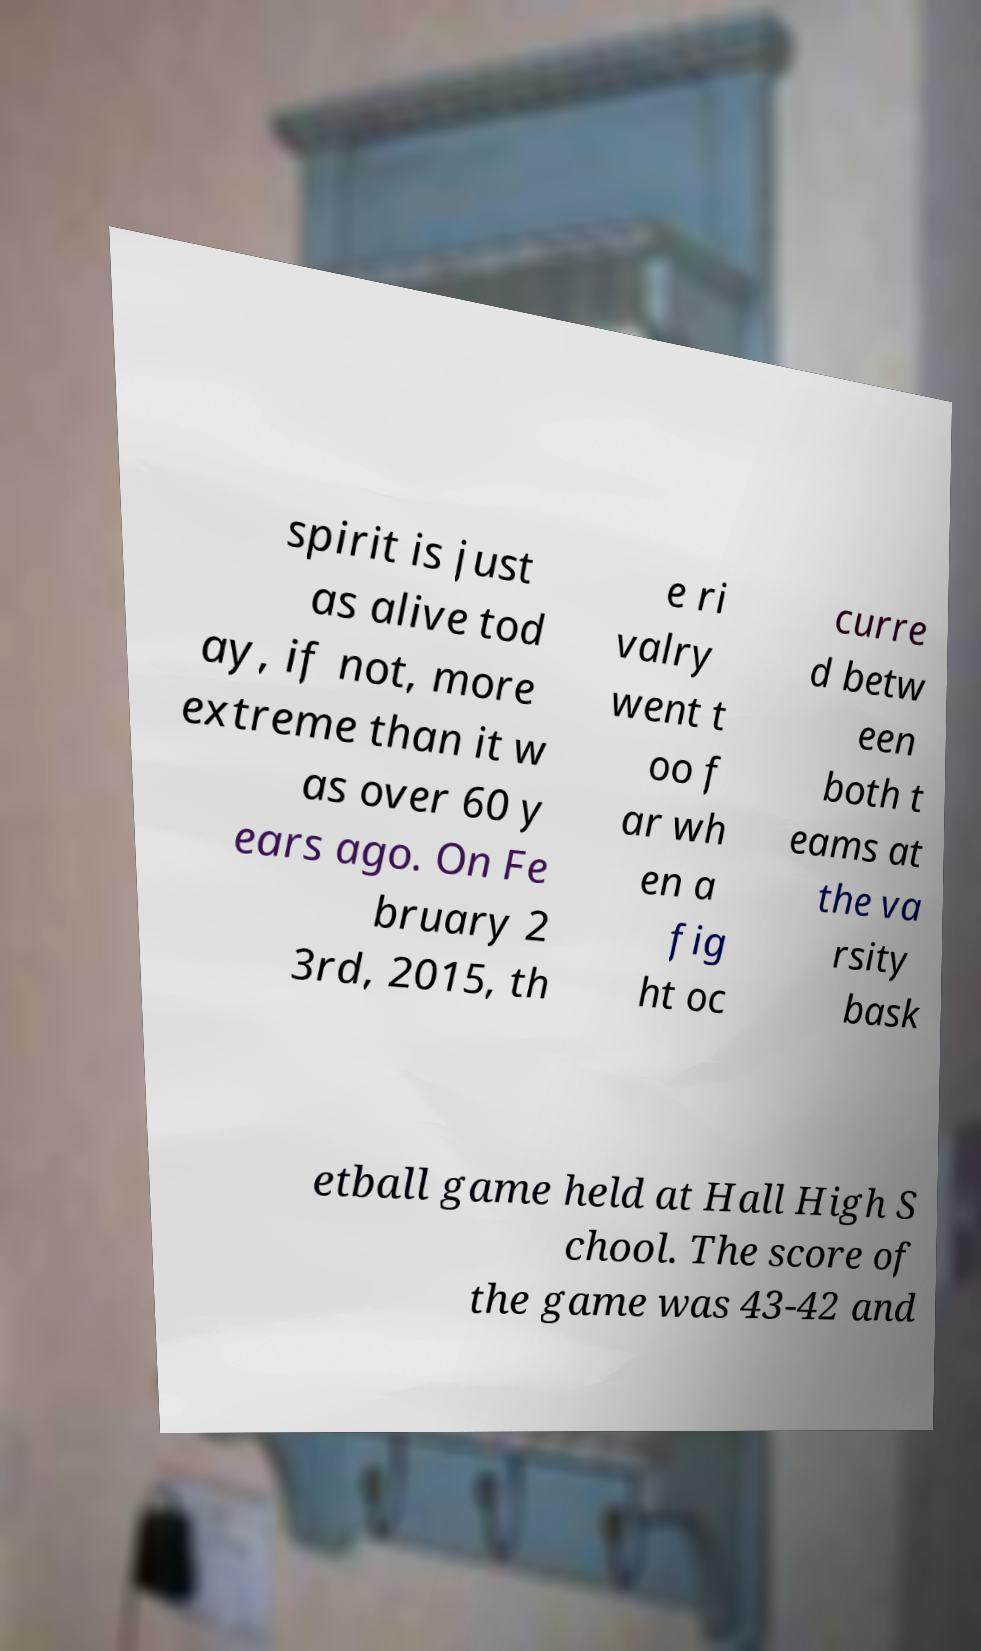Please read and relay the text visible in this image. What does it say? spirit is just as alive tod ay, if not, more extreme than it w as over 60 y ears ago. On Fe bruary 2 3rd, 2015, th e ri valry went t oo f ar wh en a fig ht oc curre d betw een both t eams at the va rsity bask etball game held at Hall High S chool. The score of the game was 43-42 and 